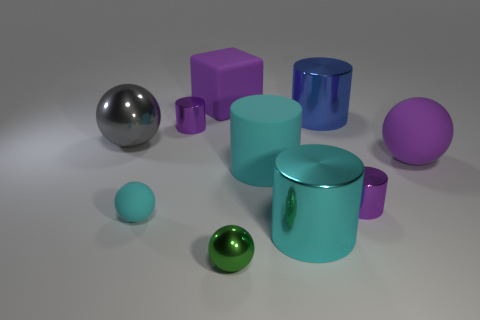What number of green objects are the same material as the blue cylinder?
Provide a short and direct response. 1. How big is the rubber ball on the right side of the purple rubber block?
Provide a succinct answer. Large. There is a large rubber object that is behind the purple sphere on the right side of the big cyan matte cylinder; what shape is it?
Offer a very short reply. Cube. How many large cyan cylinders are in front of the small purple cylinder that is right of the tiny purple metallic cylinder behind the gray metal thing?
Provide a succinct answer. 1. Is the number of cylinders that are in front of the cyan shiny cylinder less than the number of tiny red metallic cubes?
Keep it short and to the point. No. The cyan matte thing on the right side of the green metal object has what shape?
Ensure brevity in your answer.  Cylinder. The matte object to the left of the tiny purple object that is behind the purple matte thing that is on the right side of the large rubber block is what shape?
Provide a succinct answer. Sphere. How many things are cylinders or tiny rubber balls?
Offer a very short reply. 6. There is a tiny cyan thing on the left side of the purple ball; is it the same shape as the big metal thing behind the gray metallic ball?
Your answer should be very brief. No. How many large shiny things are both behind the big purple sphere and in front of the small rubber sphere?
Your response must be concise. 0. 